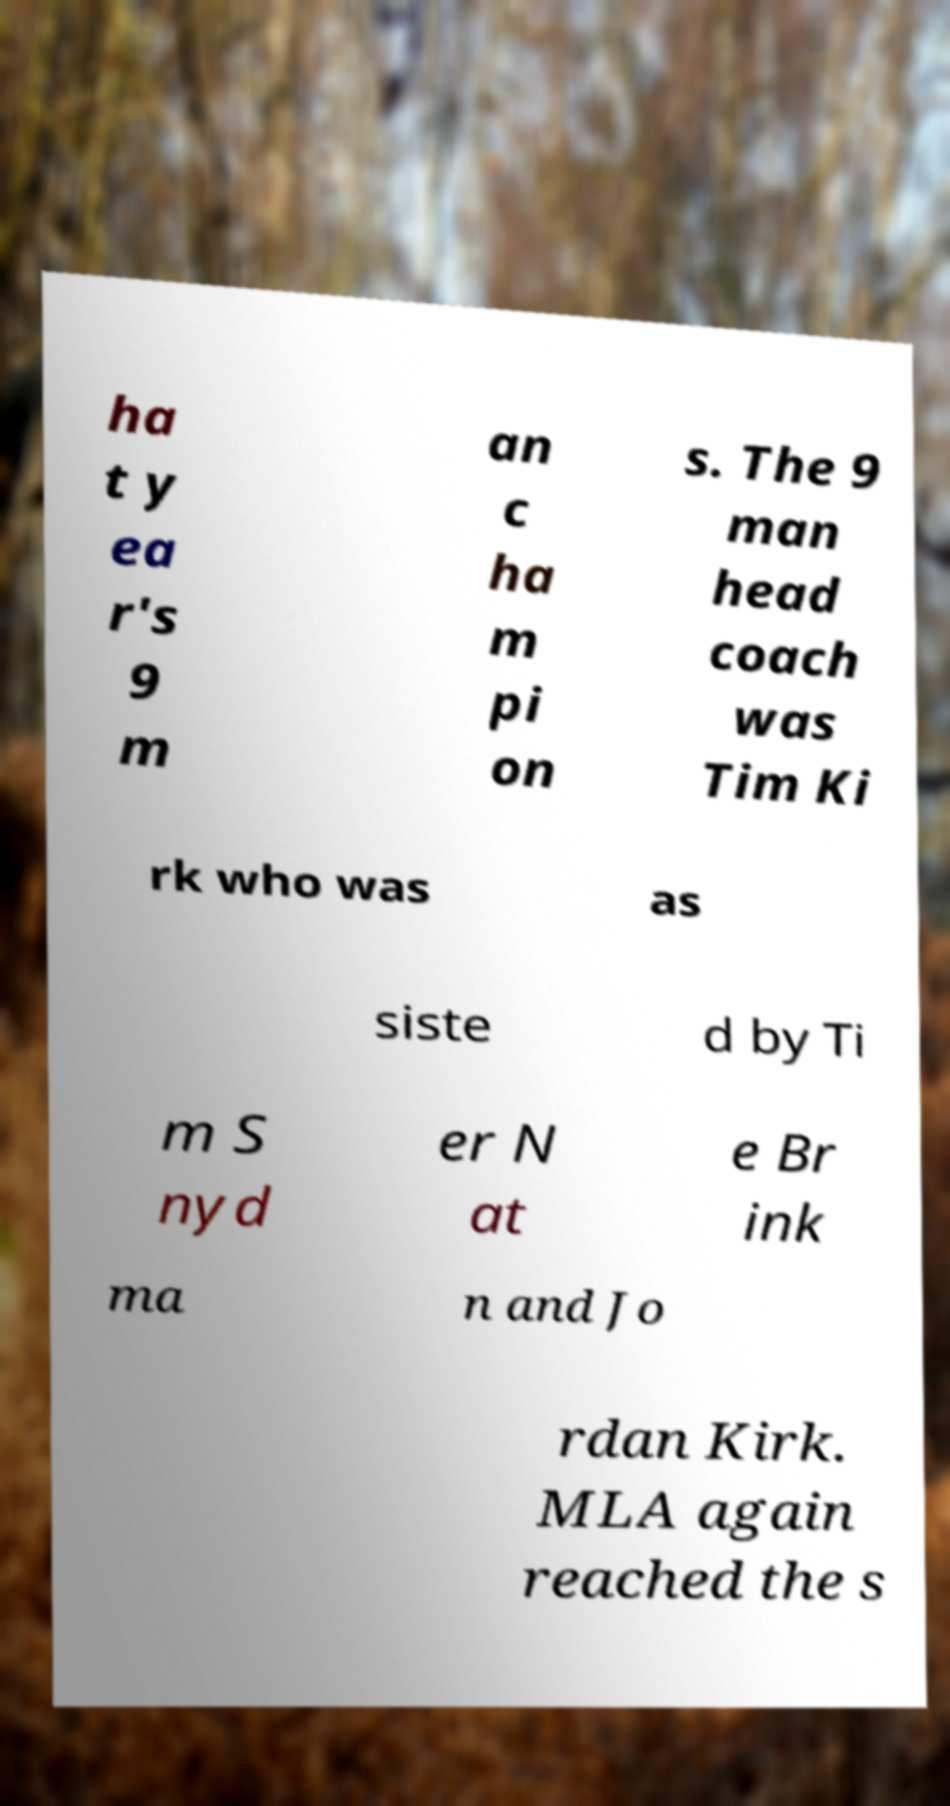Can you read and provide the text displayed in the image?This photo seems to have some interesting text. Can you extract and type it out for me? ha t y ea r's 9 m an c ha m pi on s. The 9 man head coach was Tim Ki rk who was as siste d by Ti m S nyd er N at e Br ink ma n and Jo rdan Kirk. MLA again reached the s 